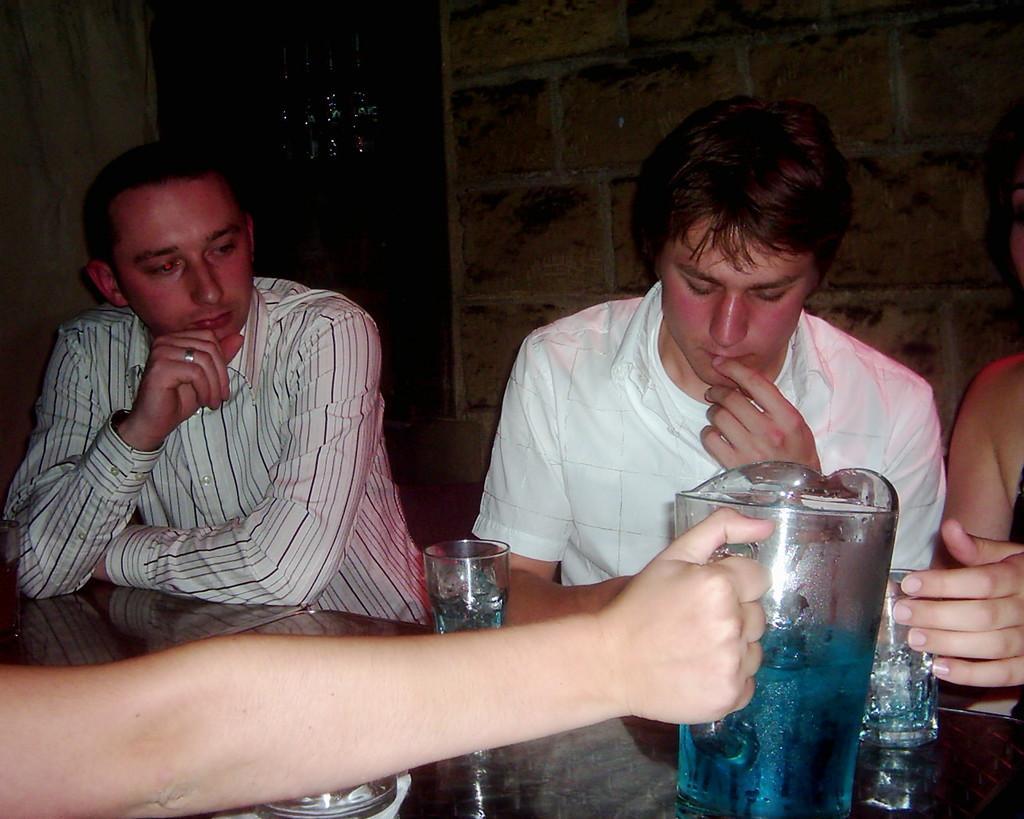Please provide a concise description of this image. This image consists of few persons sitting in the chairs. At the bottom, there is a table on which there are glasses and mug. In the background, we can see a wall and a door. 